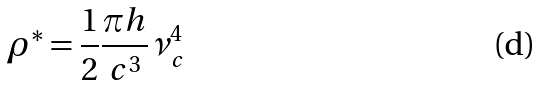Convert formula to latex. <formula><loc_0><loc_0><loc_500><loc_500>\rho ^ { * } = \frac { 1 } { 2 } \frac { \pi h } { c ^ { 3 } } \nu _ { c } ^ { 4 }</formula> 